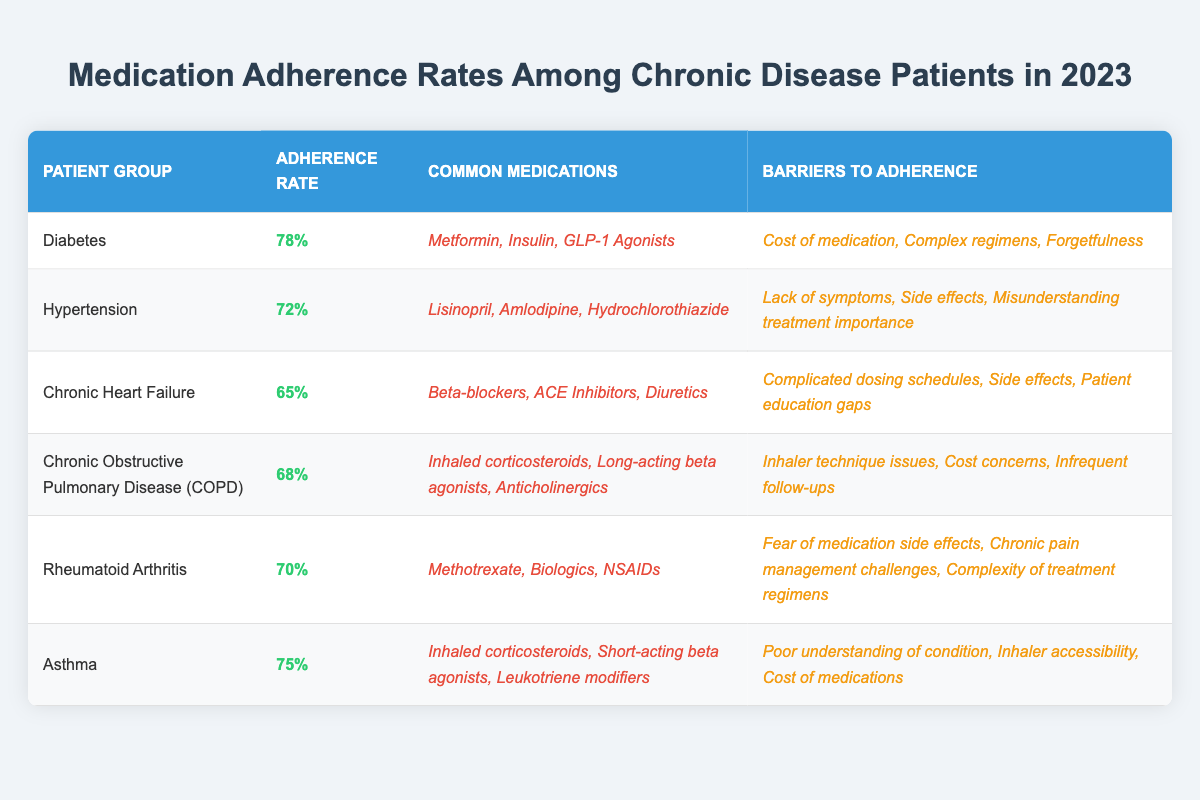What is the medication adherence rate for diabetes patients? The table shows that the adherence rate for diabetes patients is listed under the "Adherence Rate" column for the "Diabetes" row, which is 78%.
Answer: 78% Which patient group has the lowest adherence rate? By comparing the adherence rates listed in the table, "Chronic Heart Failure" has the lowest rate at 65%.
Answer: Chronic Heart Failure How many patient groups have an adherence rate above 70%? From the table, the patient groups with adherence rates above 70% are Diabetes (78%), Asthma (75%), and Rheumatoid Arthritis (70%). Therefore, there are three groups above 70%.
Answer: 3 What are the common medications for COPD? The common medications for COPD are listed in the "Common Medications" column for the "Chronic Obstructive Pulmonary Disease (COPD)" row, which includes Inhaled corticosteroids, Long-acting beta agonists, and Anticholinergics.
Answer: Inhaled corticosteroids, Long-acting beta agonists, Anticholinergics Do hypertension patients have a higher adherence rate than rheumatoid arthritis patients? The adherence rate for hypertension patients is 72%, while for rheumatoid arthritis patients, it is 70%. Since 72% is greater than 70%, hypertension patients have a higher rate.
Answer: Yes What is the difference in adherence rates between diabetes and chronic heart failure patients? The adherence rate for diabetes is 78% and for chronic heart failure it is 65%. The difference is 78% - 65% = 13%.
Answer: 13% List two barriers to adherence for diabetes patients. The table indicates the barriers to adherence for diabetes patients under the "Barriers to Adherence" column for the "Diabetes" row, which include Cost of medication, Complex regimens, and Forgetfulness. Two of these barriers are Cost of medication and Complex regimens.
Answer: Cost of medication, Complex regimens Which barriers to adherence are common for patients with chronic heart failure? The barriers for chronic heart failure patients are shown in the "Barriers to Adherence" column for the "Chronic Heart Failure" row: Complicated dosing schedules, Side effects, and Patient education gaps. These represent the common barriers.
Answer: Complicated dosing schedules, Side effects, Patient education gaps If a new medication improved adherence rates by 10% across all groups, what would be the new adherence rate for hypertension patients? The current adherence rate for hypertension is 72%. Adding 10% to this rate results in a new rate of 72% + 10% = 82%, assuming it does not exceed 100%.
Answer: 82% Which patient group faces issues related to "Cost of medications"? By examining the "Barriers to Adherence" column, it shows that Asthma, COPD, and Diabetes patients all have cost-related issues mentioned as barriers. Thus, these three groups face such issues.
Answer: Asthma, COPD, Diabetes 